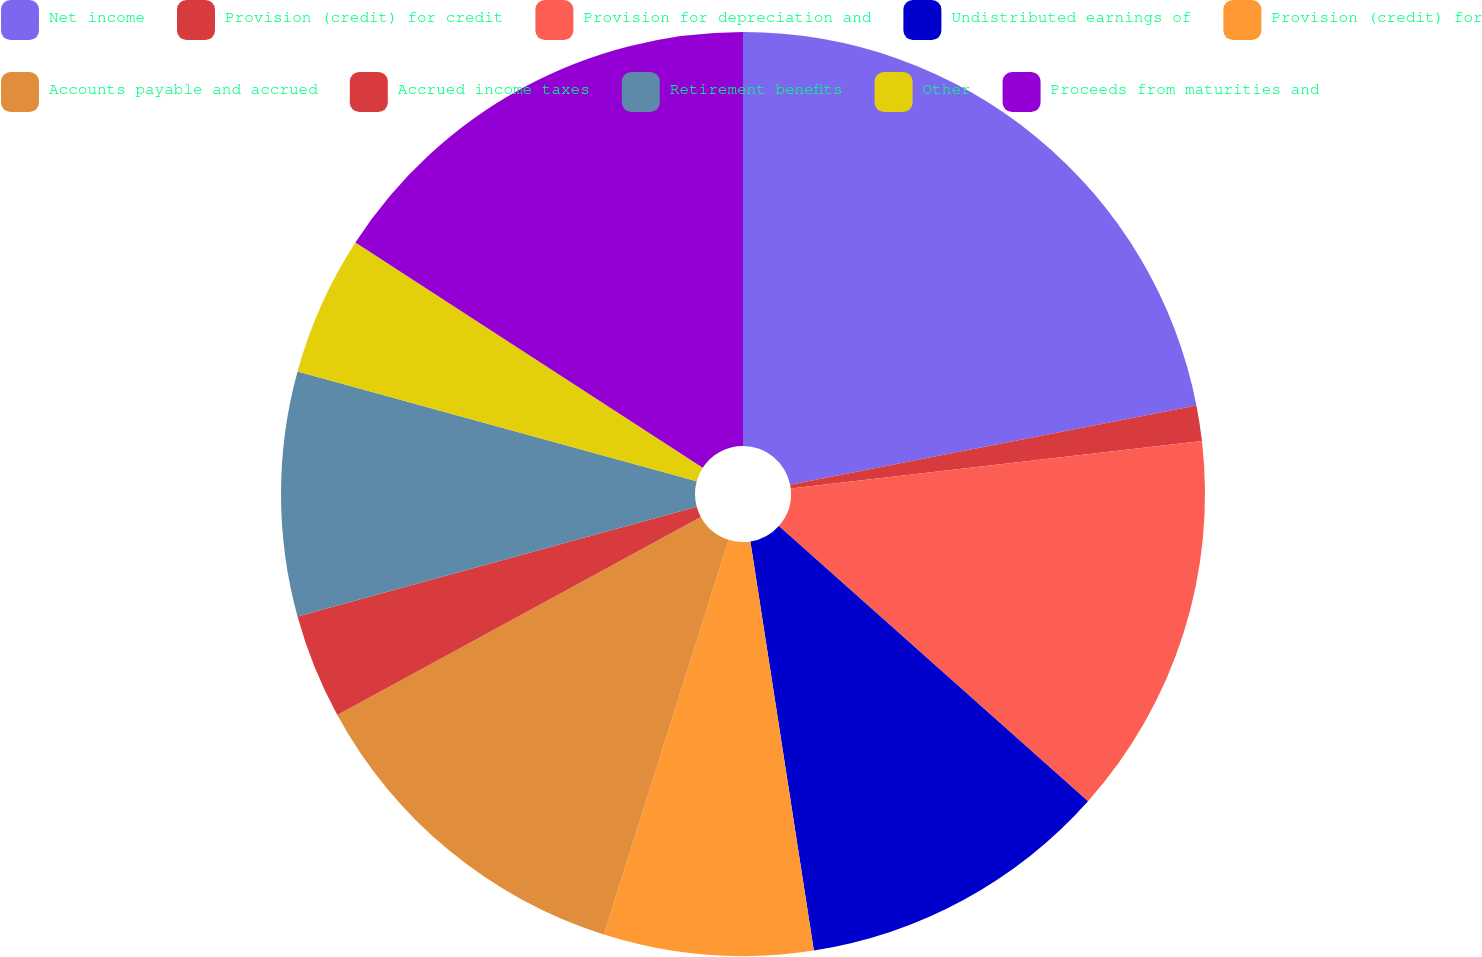<chart> <loc_0><loc_0><loc_500><loc_500><pie_chart><fcel>Net income<fcel>Provision (credit) for credit<fcel>Provision for depreciation and<fcel>Undistributed earnings of<fcel>Provision (credit) for<fcel>Accounts payable and accrued<fcel>Accrued income taxes<fcel>Retirement benefits<fcel>Other<fcel>Proceeds from maturities and<nl><fcel>21.93%<fcel>1.24%<fcel>13.41%<fcel>10.97%<fcel>7.32%<fcel>12.19%<fcel>3.67%<fcel>8.54%<fcel>4.89%<fcel>15.84%<nl></chart> 